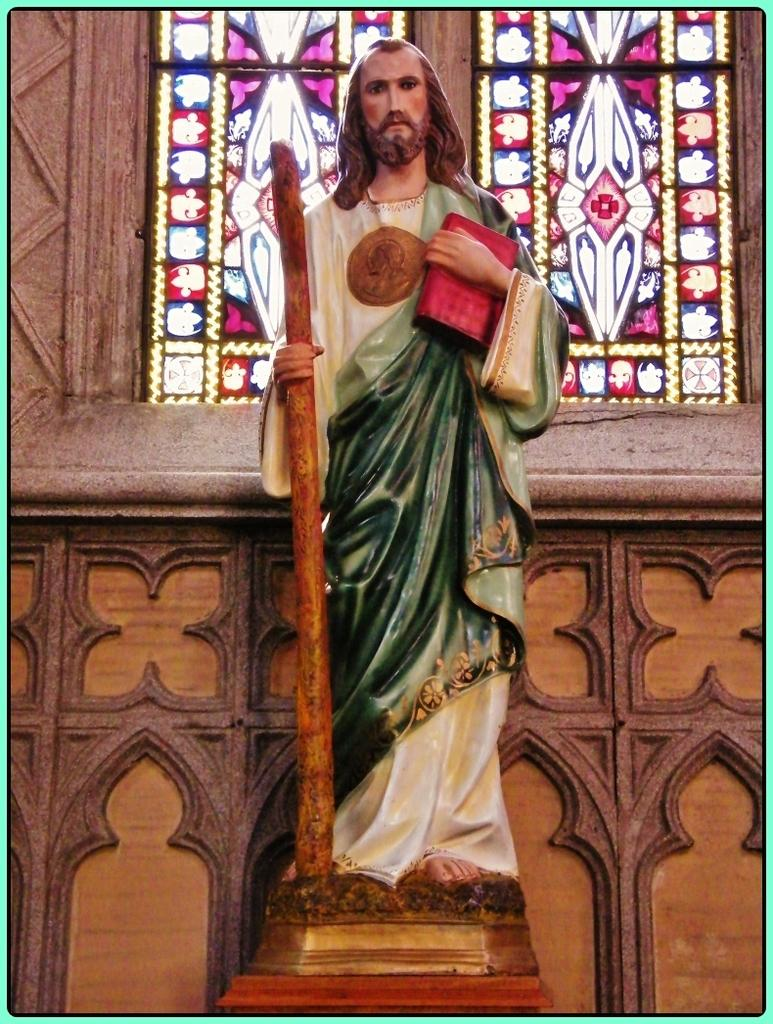What is the main subject of the picture? The main subject of the picture is a Jesus statue. What is the statue holding in its hands? The statue is holding a stick and a book. What can be seen in the background of the image? There are stained windows and a wall with a design in the background of the image. What type of notebook is the statue using to write on the cushion? There is no notebook or cushion present in the image; the statue is holding a stick and a book. 